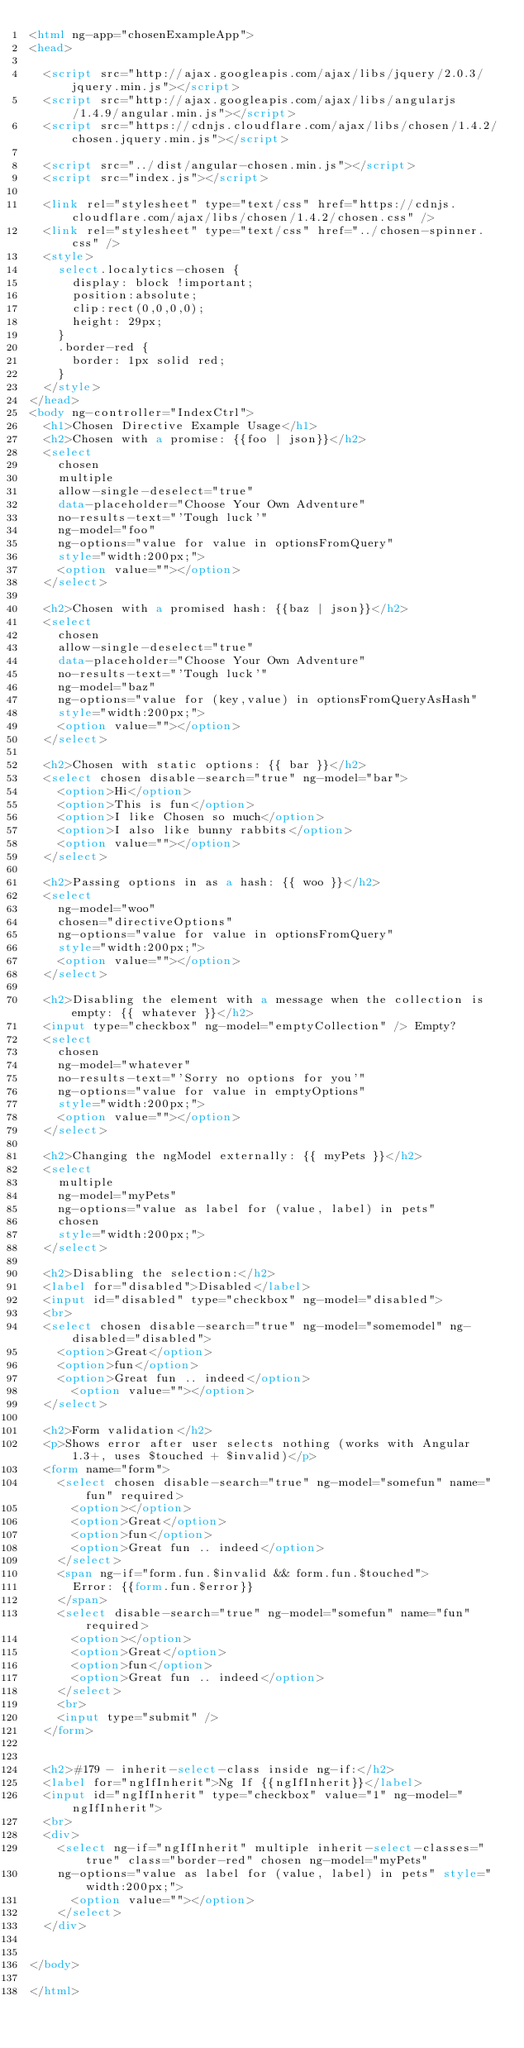Convert code to text. <code><loc_0><loc_0><loc_500><loc_500><_HTML_><html ng-app="chosenExampleApp">
<head>

  <script src="http://ajax.googleapis.com/ajax/libs/jquery/2.0.3/jquery.min.js"></script>
  <script src="http://ajax.googleapis.com/ajax/libs/angularjs/1.4.9/angular.min.js"></script>
  <script src="https://cdnjs.cloudflare.com/ajax/libs/chosen/1.4.2/chosen.jquery.min.js"></script>

  <script src="../dist/angular-chosen.min.js"></script>
  <script src="index.js"></script>

  <link rel="stylesheet" type="text/css" href="https://cdnjs.cloudflare.com/ajax/libs/chosen/1.4.2/chosen.css" />
  <link rel="stylesheet" type="text/css" href="../chosen-spinner.css" />
  <style>
    select.localytics-chosen {
      display: block !important;
      position:absolute;
      clip:rect(0,0,0,0);
      height: 29px;
    }
    .border-red {
      border: 1px solid red;
    }
  </style>
</head>
<body ng-controller="IndexCtrl">
  <h1>Chosen Directive Example Usage</h1>
  <h2>Chosen with a promise: {{foo | json}}</h2>
  <select
    chosen
    multiple
    allow-single-deselect="true"
    data-placeholder="Choose Your Own Adventure"
    no-results-text="'Tough luck'"
    ng-model="foo"
    ng-options="value for value in optionsFromQuery"
    style="width:200px;">
    <option value=""></option>
  </select>

  <h2>Chosen with a promised hash: {{baz | json}}</h2>
  <select
    chosen
    allow-single-deselect="true"
    data-placeholder="Choose Your Own Adventure"
    no-results-text="'Tough luck'"
    ng-model="baz"
    ng-options="value for (key,value) in optionsFromQueryAsHash"
    style="width:200px;">
    <option value=""></option>
  </select>

  <h2>Chosen with static options: {{ bar }}</h2>
  <select chosen disable-search="true" ng-model="bar">
    <option>Hi</option>
    <option>This is fun</option>
    <option>I like Chosen so much</option>
    <option>I also like bunny rabbits</option>
    <option value=""></option>
  </select>

  <h2>Passing options in as a hash: {{ woo }}</h2>
  <select
    ng-model="woo"
    chosen="directiveOptions"
    ng-options="value for value in optionsFromQuery"
    style="width:200px;">
    <option value=""></option>
  </select>

  <h2>Disabling the element with a message when the collection is empty: {{ whatever }}</h2>
  <input type="checkbox" ng-model="emptyCollection" /> Empty?
  <select
    chosen
    ng-model="whatever"
    no-results-text="'Sorry no options for you'"
    ng-options="value for value in emptyOptions"
    style="width:200px;">
    <option value=""></option>
  </select>

  <h2>Changing the ngModel externally: {{ myPets }}</h2>
  <select
    multiple
    ng-model="myPets"
    ng-options="value as label for (value, label) in pets"
    chosen
    style="width:200px;">
  </select>

  <h2>Disabling the selection:</h2>
  <label for="disabled">Disabled</label>
  <input id="disabled" type="checkbox" ng-model="disabled">
  <br>
  <select chosen disable-search="true" ng-model="somemodel" ng-disabled="disabled">
    <option>Great</option>
    <option>fun</option>
    <option>Great fun .. indeed</option>
      <option value=""></option>
  </select>

  <h2>Form validation</h2>
  <p>Shows error after user selects nothing (works with Angular 1.3+, uses $touched + $invalid)</p>
  <form name="form">
    <select chosen disable-search="true" ng-model="somefun" name="fun" required>
      <option></option>
      <option>Great</option>
      <option>fun</option>
      <option>Great fun .. indeed</option>
    </select>
    <span ng-if="form.fun.$invalid && form.fun.$touched">
      Error: {{form.fun.$error}}
    </span>
    <select disable-search="true" ng-model="somefun" name="fun" required>
      <option></option>
      <option>Great</option>
      <option>fun</option>
      <option>Great fun .. indeed</option>
    </select>
    <br>
    <input type="submit" />
  </form>


  <h2>#179 - inherit-select-class inside ng-if:</h2>
  <label for="ngIfInherit">Ng If {{ngIfInherit}}</label>
  <input id="ngIfInherit" type="checkbox" value="1" ng-model="ngIfInherit">
  <br>
  <div>
    <select ng-if="ngIfInherit" multiple inherit-select-classes="true" class="border-red" chosen ng-model="myPets"
    ng-options="value as label for (value, label) in pets" style="width:200px;">
      <option value=""></option>
    </select>
  </div>


</body>

</html>
</code> 